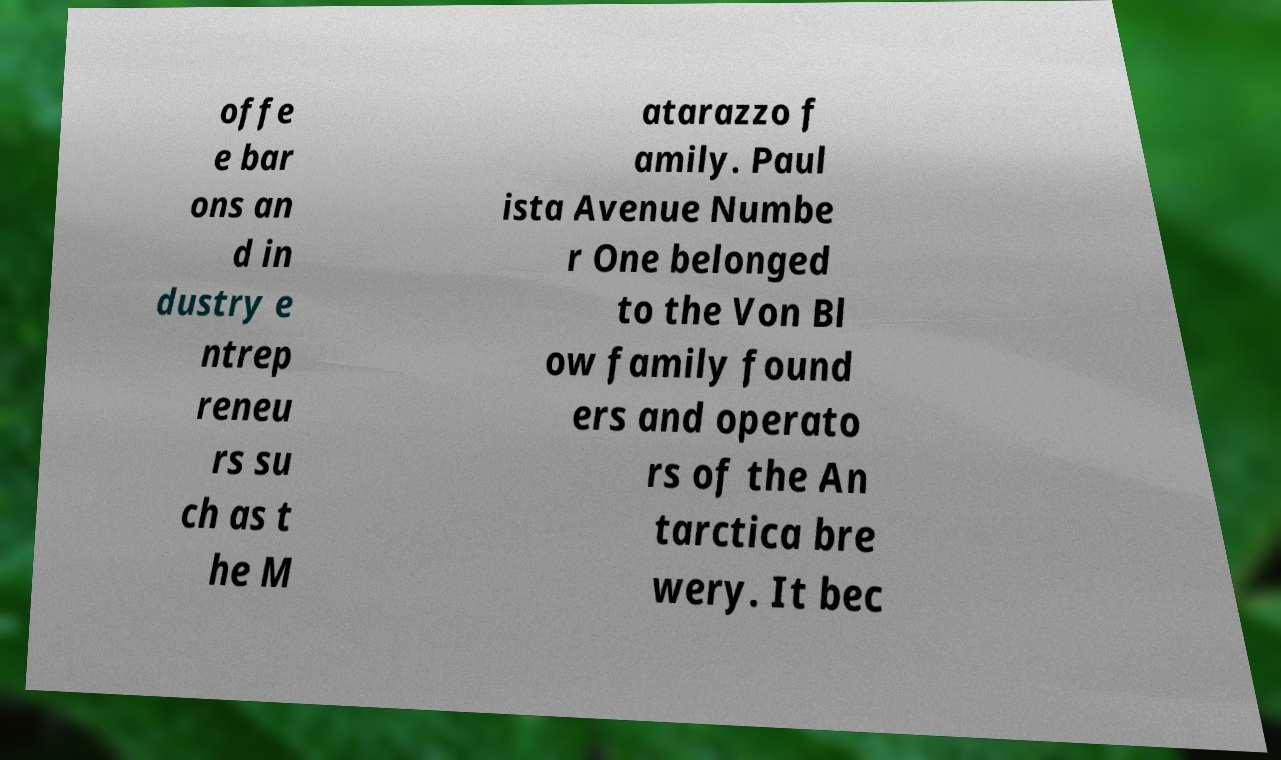Can you accurately transcribe the text from the provided image for me? offe e bar ons an d in dustry e ntrep reneu rs su ch as t he M atarazzo f amily. Paul ista Avenue Numbe r One belonged to the Von Bl ow family found ers and operato rs of the An tarctica bre wery. It bec 